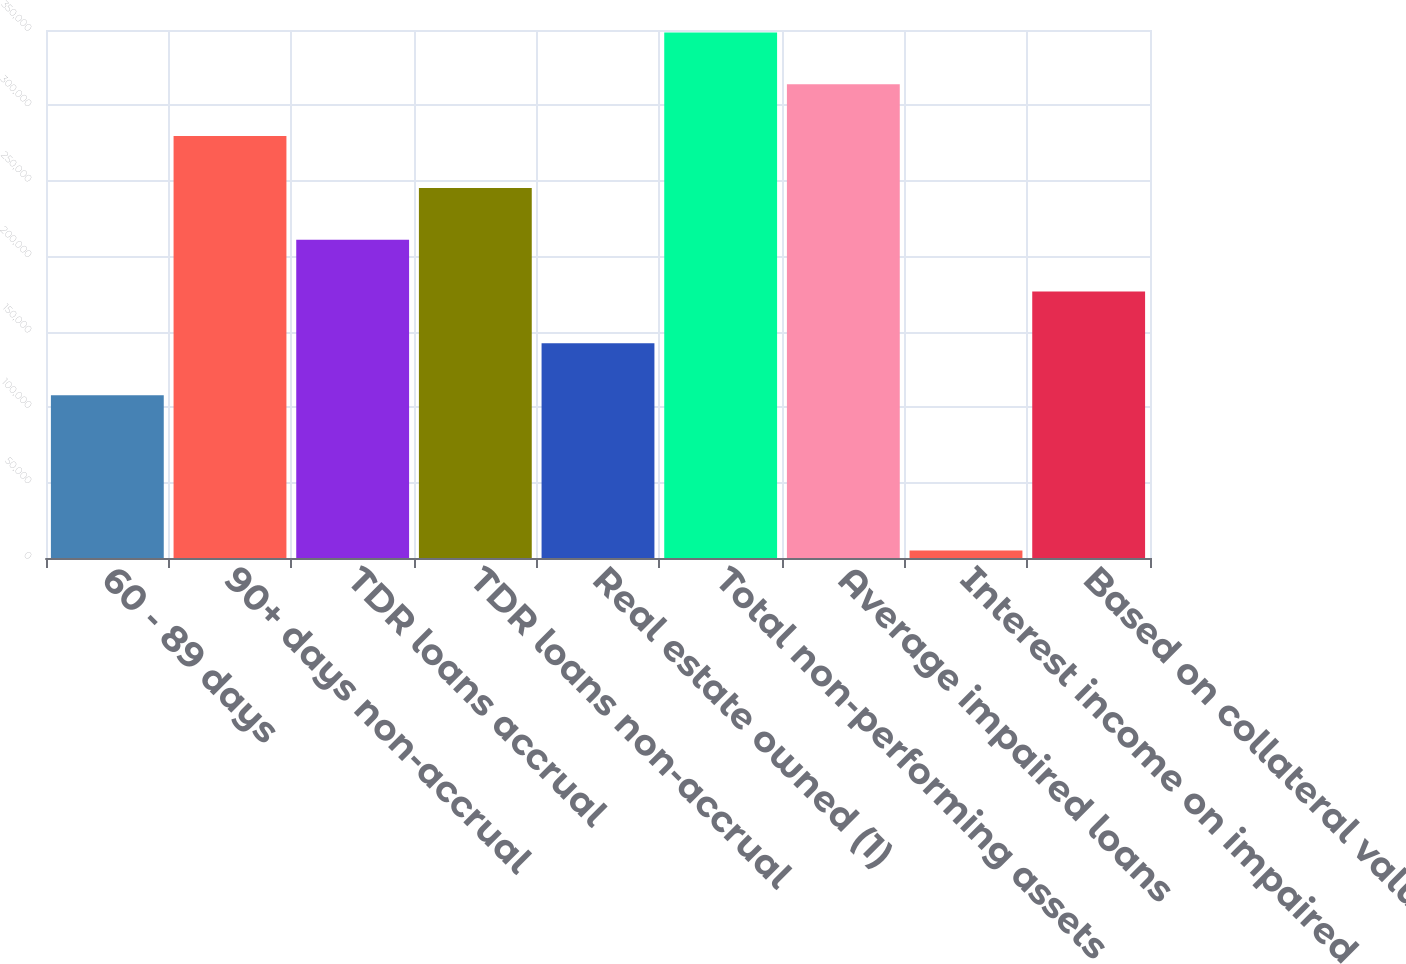Convert chart to OTSL. <chart><loc_0><loc_0><loc_500><loc_500><bar_chart><fcel>60 - 89 days<fcel>90+ days non-accrual<fcel>TDR loans accrual<fcel>TDR loans non-accrual<fcel>Real estate owned (1)<fcel>Total non-performing assets<fcel>Average impaired loans<fcel>Interest income on impaired<fcel>Based on collateral value<nl><fcel>107961<fcel>279685<fcel>210995<fcel>245340<fcel>142306<fcel>348374<fcel>314029<fcel>4927<fcel>176650<nl></chart> 